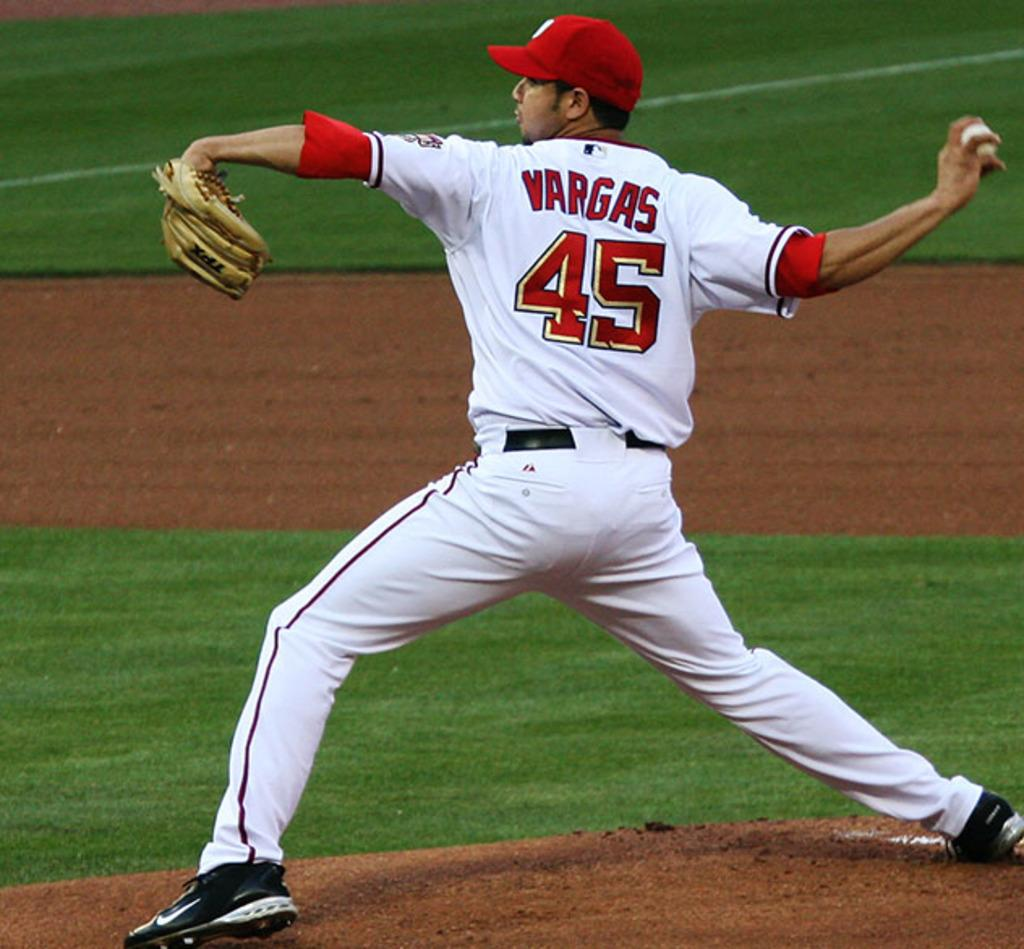<image>
Offer a succinct explanation of the picture presented. Pitcher 45, named Vargas winds up for the pitch. 